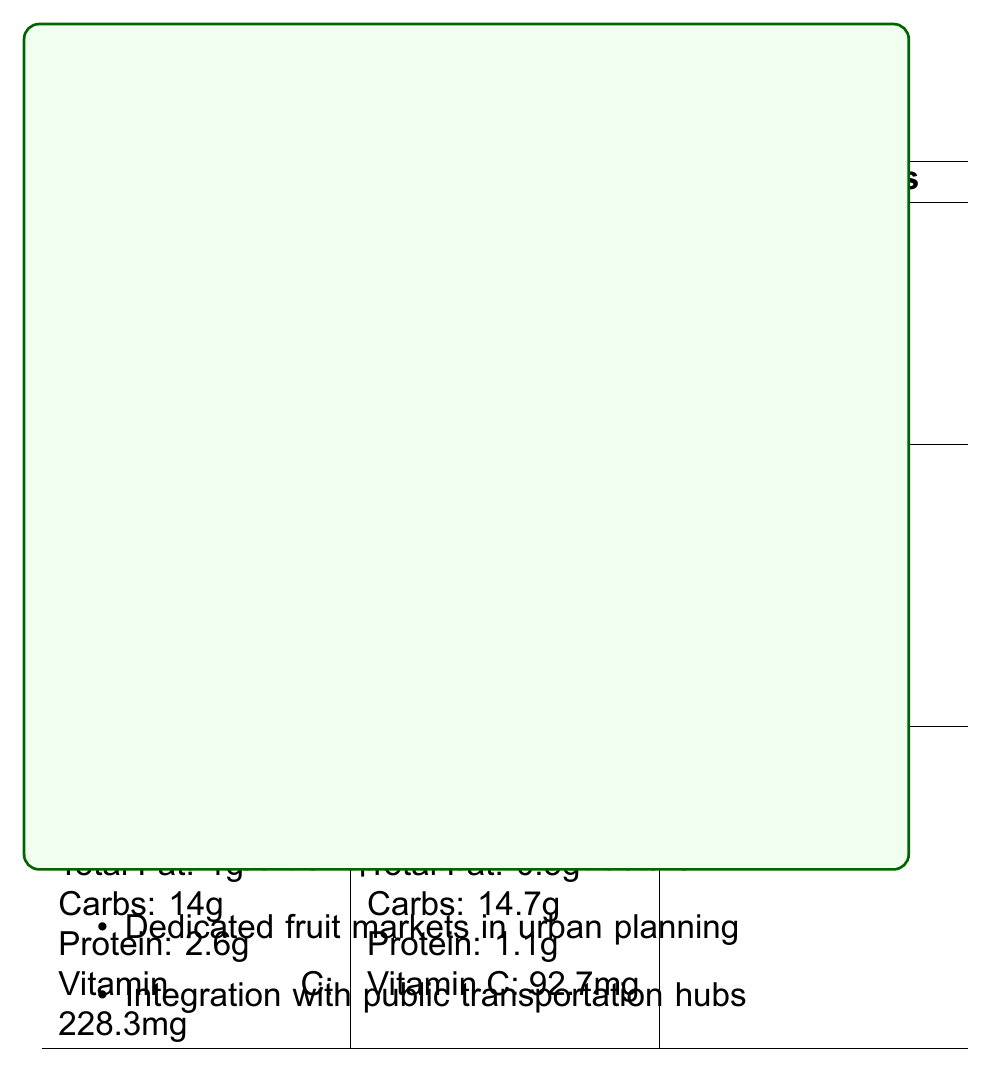what is the serving size for Mango (Fazli)? The document specifies that the serving size for Mango (Fazli) is 100g.
Answer: 100g which local fruit has the highest protein content? According to the document, Guava (Swarupkathi) has 2.6g of protein, which is the highest among the local fruits listed.
Answer: Guava (Swarupkathi) Does Jackfruit (Khaja) contain more Vitamin C than Orange (Valencia)? Jackfruit (Khaja) contains 13.7mg of Vitamin C, while Orange (Valencia) has 53.2mg according to the document.
Answer: No how many calories are in a 100g serving of Apple (Fuji)? The document specifies that a 100g serving of Apple (Fuji) contains 52 calories.
Answer: 52 which imported fruit has the highest carbohydrate content? The document shows that Kiwi (Hayward) contains 14.7g of carbohydrates, the highest among the imported fruits listed.
Answer: Kiwi (Hayward) which fruit has more total fat: Mango (Fazli) or Kiwi (Hayward)? The document shows Mango (Fazli) has 0.4g of total fat compared to Kiwi (Hayward) with 0.5g of total fat.
Answer: Mango (Fazli) which local fruit provides the most potassium? A. Mango (Fazli) B. Jackfruit (Khaja) C. Guava (Swarupkathi) According to the document, Jackfruit (Khaja) provides 448mg of potassium, more than Mango (Fazli) and Guava (Swarupkathi).
Answer: B which imported fruit has the lowest calorie content? A. Apple (Fuji) B. Orange (Valencia) C. Kiwi (Hayward) The document indicates that Orange (Valencia) has the lowest calorie content at 47 calories per 100g.
Answer: B is there any fruit listed that has trans fat content? The document does not list any trans fat content for any of the fruits.
Answer: No describe the main idea of the document. The document presents a comparative nutritional analysis of local versus imported fruits in Dhaka markets, along with urban planning considerations to support the local fruit industry, addressing issues like cold storage, transportation, and dedicated fruit markets.
Answer: The document compares the nutrient content of local fruits such as Mango, Jackfruit, and Guava with imported fruits such as Apple, Orange, and Kiwi commonly found in Dhaka markets. It provides detailed nutritional information per 100g serving for each fruit and highlights urban planning considerations for improving fruit storage, transportation, and distribution in Dhaka. what strategies are suggested for promoting local fruit cultivation? The document mentions promoting local fruit cultivation to reduce reliance on imports but does not provide specific strategies for achieving this.
Answer: Not enough information 